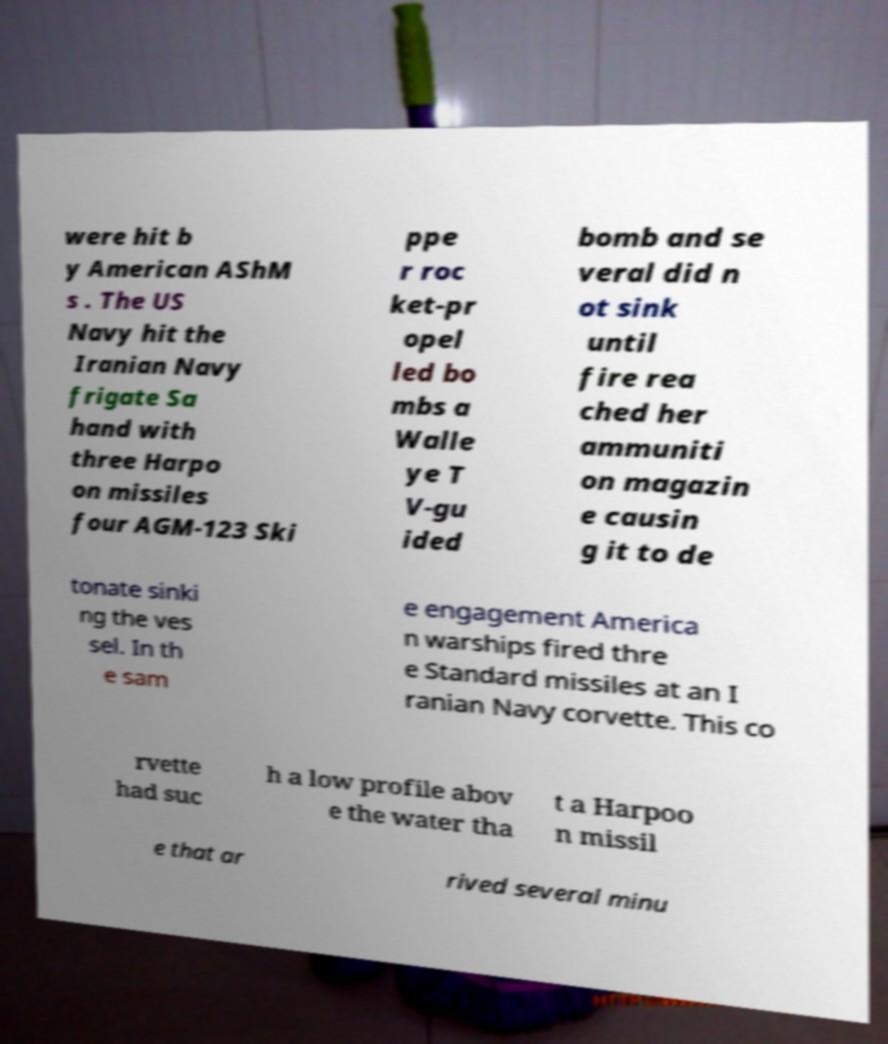Please read and relay the text visible in this image. What does it say? were hit b y American AShM s . The US Navy hit the Iranian Navy frigate Sa hand with three Harpo on missiles four AGM-123 Ski ppe r roc ket-pr opel led bo mbs a Walle ye T V-gu ided bomb and se veral did n ot sink until fire rea ched her ammuniti on magazin e causin g it to de tonate sinki ng the ves sel. In th e sam e engagement America n warships fired thre e Standard missiles at an I ranian Navy corvette. This co rvette had suc h a low profile abov e the water tha t a Harpoo n missil e that ar rived several minu 